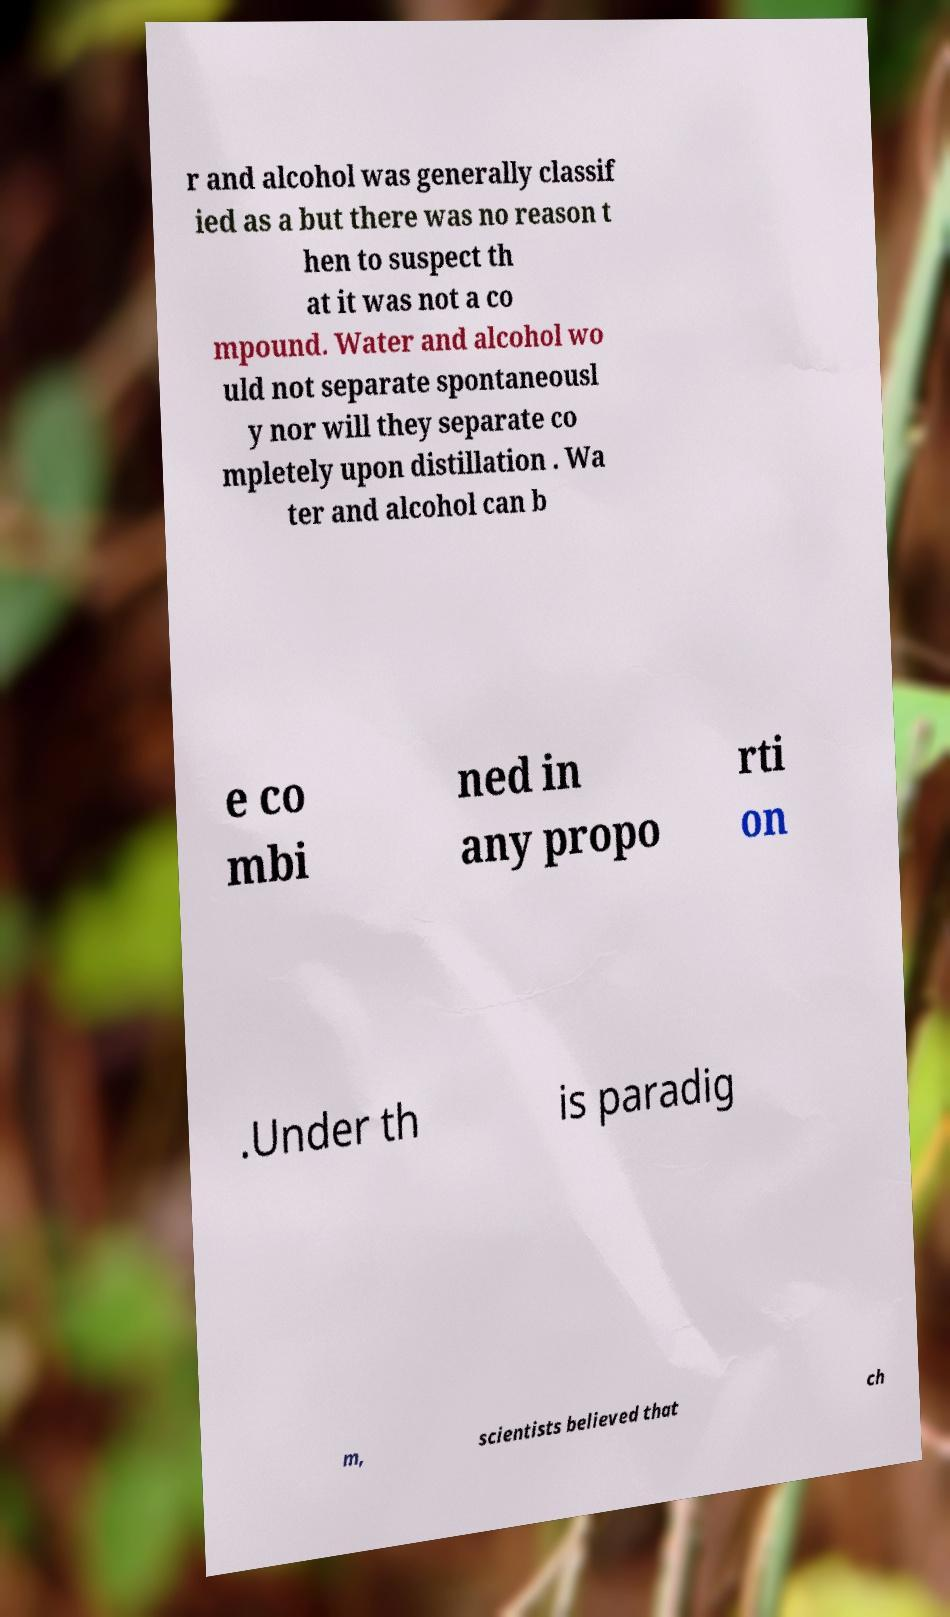Can you read and provide the text displayed in the image?This photo seems to have some interesting text. Can you extract and type it out for me? r and alcohol was generally classif ied as a but there was no reason t hen to suspect th at it was not a co mpound. Water and alcohol wo uld not separate spontaneousl y nor will they separate co mpletely upon distillation . Wa ter and alcohol can b e co mbi ned in any propo rti on .Under th is paradig m, scientists believed that ch 